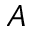Convert formula to latex. <formula><loc_0><loc_0><loc_500><loc_500>A</formula> 